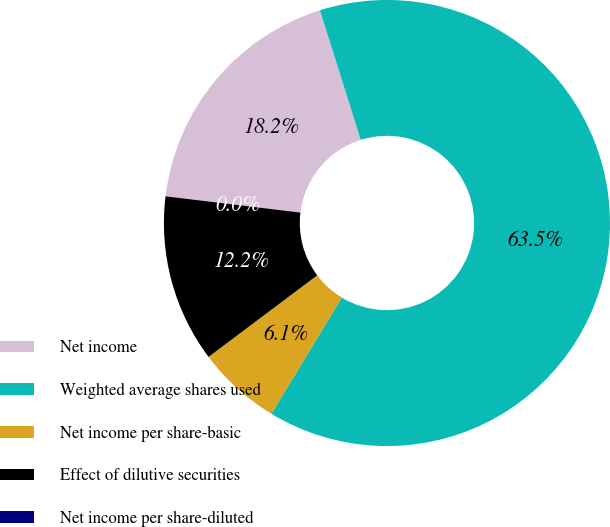<chart> <loc_0><loc_0><loc_500><loc_500><pie_chart><fcel>Net income<fcel>Weighted average shares used<fcel>Net income per share-basic<fcel>Effect of dilutive securities<fcel>Net income per share-diluted<nl><fcel>18.23%<fcel>63.53%<fcel>6.08%<fcel>12.16%<fcel>0.0%<nl></chart> 